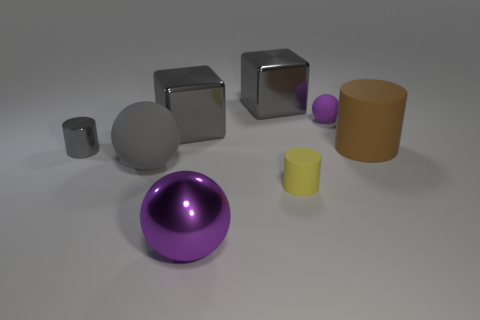Do the metal ball and the tiny ball have the same color?
Your answer should be very brief. Yes. Are there more matte balls behind the large cylinder than large gray blocks that are to the right of the tiny yellow rubber thing?
Offer a terse response. Yes. There is a cylinder that is in front of the small gray object; is its size the same as the purple object that is behind the big purple thing?
Keep it short and to the point. Yes. What is the shape of the gray rubber object?
Your response must be concise. Sphere. The object that is the same color as the shiny ball is what size?
Your answer should be very brief. Small. There is a cylinder that is made of the same material as the large brown object; what is its color?
Your answer should be compact. Yellow. Are the gray cylinder and the thing in front of the yellow thing made of the same material?
Your response must be concise. Yes. What is the color of the small rubber cylinder?
Keep it short and to the point. Yellow. The gray thing that is the same material as the tiny ball is what size?
Make the answer very short. Large. How many large gray balls are on the right side of the block behind the ball that is behind the small metal cylinder?
Your response must be concise. 0. 